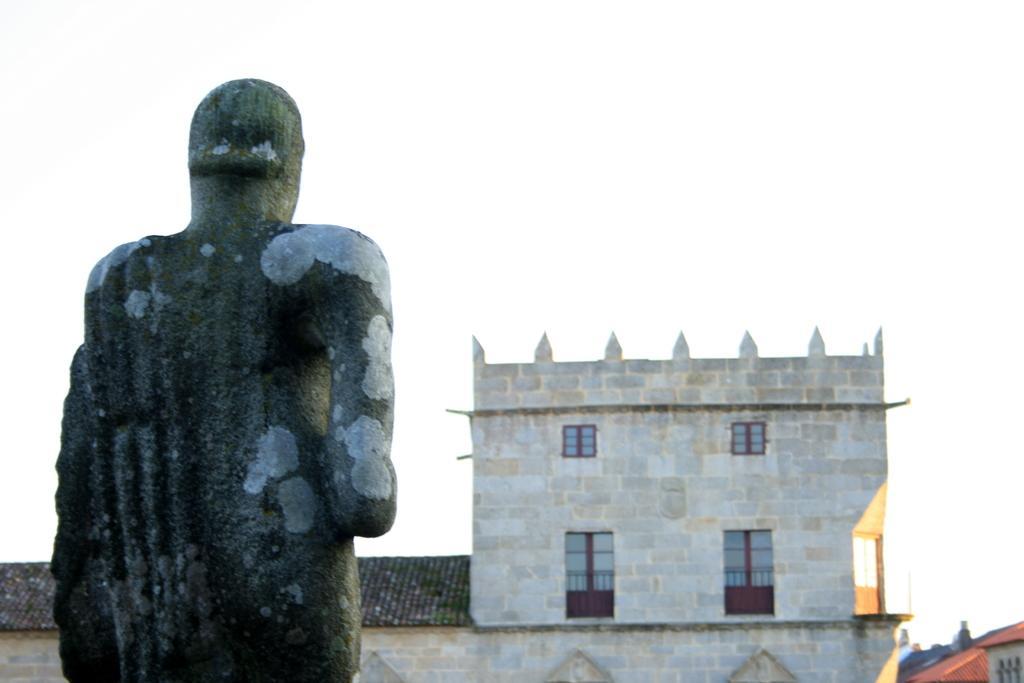Can you describe this image briefly? In the foreground of the image there is a statue. In the background of the image there is a building. At the top of the image there is sky. 